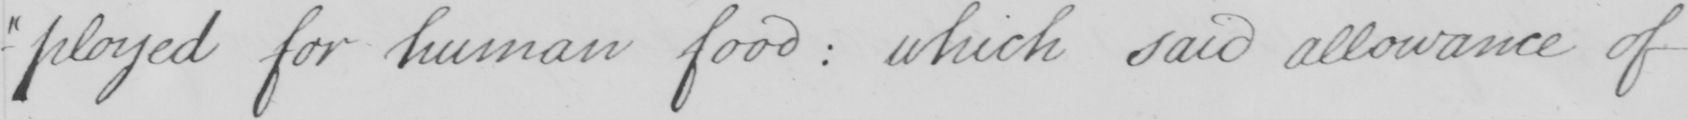Can you read and transcribe this handwriting? -ployed for human food :  which said allowance of 